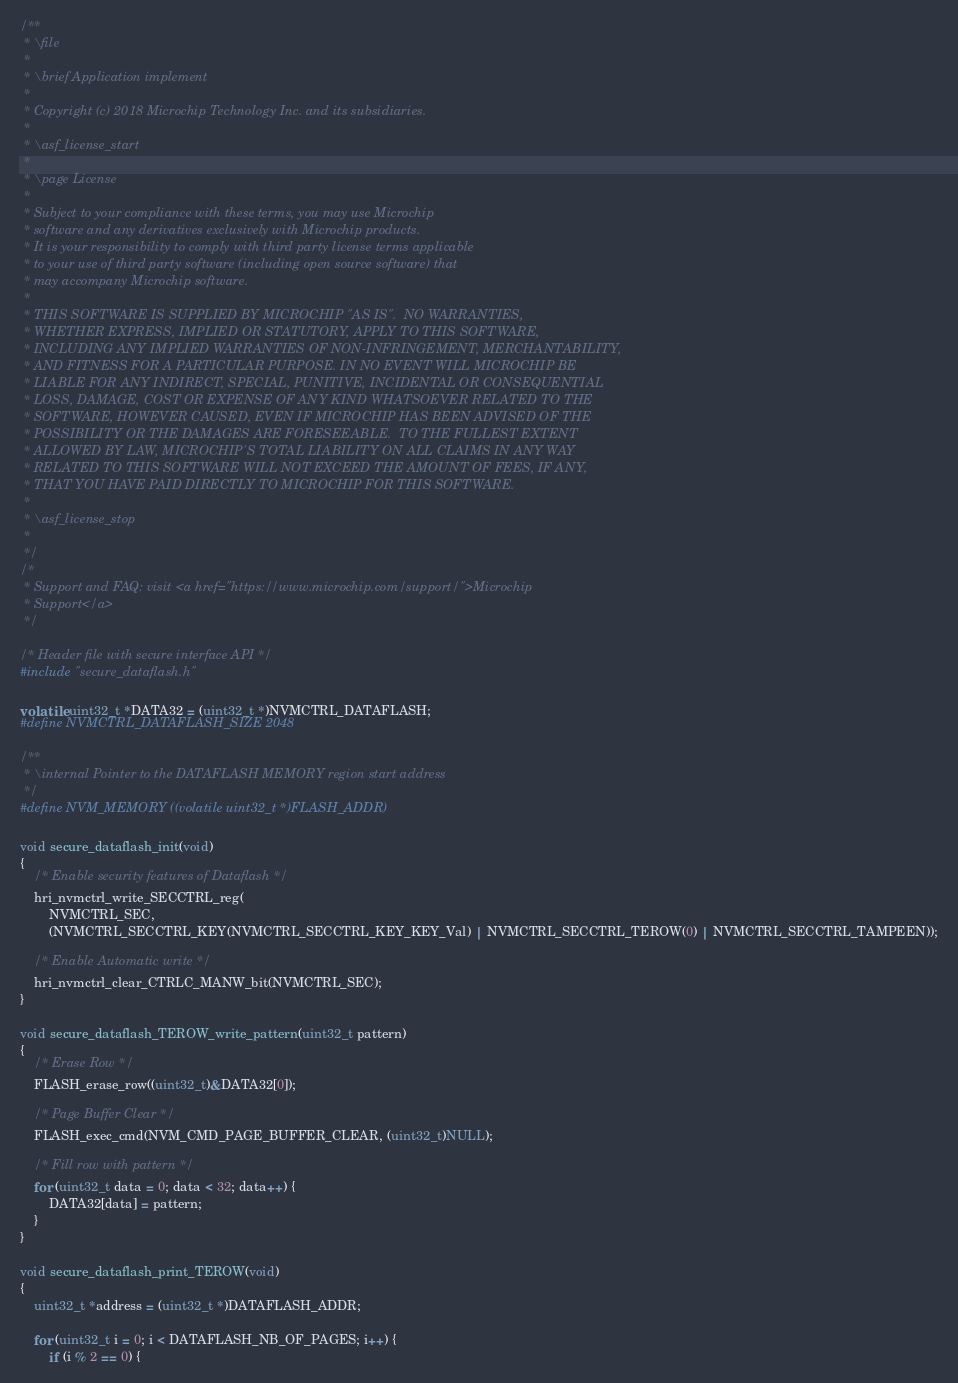<code> <loc_0><loc_0><loc_500><loc_500><_C_>/**
 * \file
 *
 * \brief Application implement
 *
 * Copyright (c) 2018 Microchip Technology Inc. and its subsidiaries.
 *
 * \asf_license_start
 *
 * \page License
 *
 * Subject to your compliance with these terms, you may use Microchip
 * software and any derivatives exclusively with Microchip products.
 * It is your responsibility to comply with third party license terms applicable
 * to your use of third party software (including open source software) that
 * may accompany Microchip software.
 *
 * THIS SOFTWARE IS SUPPLIED BY MICROCHIP "AS IS".  NO WARRANTIES,
 * WHETHER EXPRESS, IMPLIED OR STATUTORY, APPLY TO THIS SOFTWARE,
 * INCLUDING ANY IMPLIED WARRANTIES OF NON-INFRINGEMENT, MERCHANTABILITY,
 * AND FITNESS FOR A PARTICULAR PURPOSE. IN NO EVENT WILL MICROCHIP BE
 * LIABLE FOR ANY INDIRECT, SPECIAL, PUNITIVE, INCIDENTAL OR CONSEQUENTIAL
 * LOSS, DAMAGE, COST OR EXPENSE OF ANY KIND WHATSOEVER RELATED TO THE
 * SOFTWARE, HOWEVER CAUSED, EVEN IF MICROCHIP HAS BEEN ADVISED OF THE
 * POSSIBILITY OR THE DAMAGES ARE FORESEEABLE.  TO THE FULLEST EXTENT
 * ALLOWED BY LAW, MICROCHIP'S TOTAL LIABILITY ON ALL CLAIMS IN ANY WAY
 * RELATED TO THIS SOFTWARE WILL NOT EXCEED THE AMOUNT OF FEES, IF ANY,
 * THAT YOU HAVE PAID DIRECTLY TO MICROCHIP FOR THIS SOFTWARE.
 *
 * \asf_license_stop
 *
 */
/*
 * Support and FAQ: visit <a href="https://www.microchip.com/support/">Microchip
 * Support</a>
 */

/* Header file with secure interface API */
#include "secure_dataflash.h"

volatile uint32_t *DATA32 = (uint32_t *)NVMCTRL_DATAFLASH;
#define NVMCTRL_DATAFLASH_SIZE 2048

/**
 * \internal Pointer to the DATAFLASH MEMORY region start address
 */
#define NVM_MEMORY ((volatile uint32_t *)FLASH_ADDR)

void secure_dataflash_init(void)
{
	/* Enable security features of Dataflash */
	hri_nvmctrl_write_SECCTRL_reg(
	    NVMCTRL_SEC,
	    (NVMCTRL_SECCTRL_KEY(NVMCTRL_SECCTRL_KEY_KEY_Val) | NVMCTRL_SECCTRL_TEROW(0) | NVMCTRL_SECCTRL_TAMPEEN));

	/* Enable Automatic write */
	hri_nvmctrl_clear_CTRLC_MANW_bit(NVMCTRL_SEC);
}

void secure_dataflash_TEROW_write_pattern(uint32_t pattern)
{
	/* Erase Row */
	FLASH_erase_row((uint32_t)&DATA32[0]);

	/* Page Buffer Clear */
	FLASH_exec_cmd(NVM_CMD_PAGE_BUFFER_CLEAR, (uint32_t)NULL);

	/* Fill row with pattern */
	for (uint32_t data = 0; data < 32; data++) {
		DATA32[data] = pattern;
	}
}

void secure_dataflash_print_TEROW(void)
{
	uint32_t *address = (uint32_t *)DATAFLASH_ADDR;

	for (uint32_t i = 0; i < DATAFLASH_NB_OF_PAGES; i++) {
		if (i % 2 == 0) {</code> 